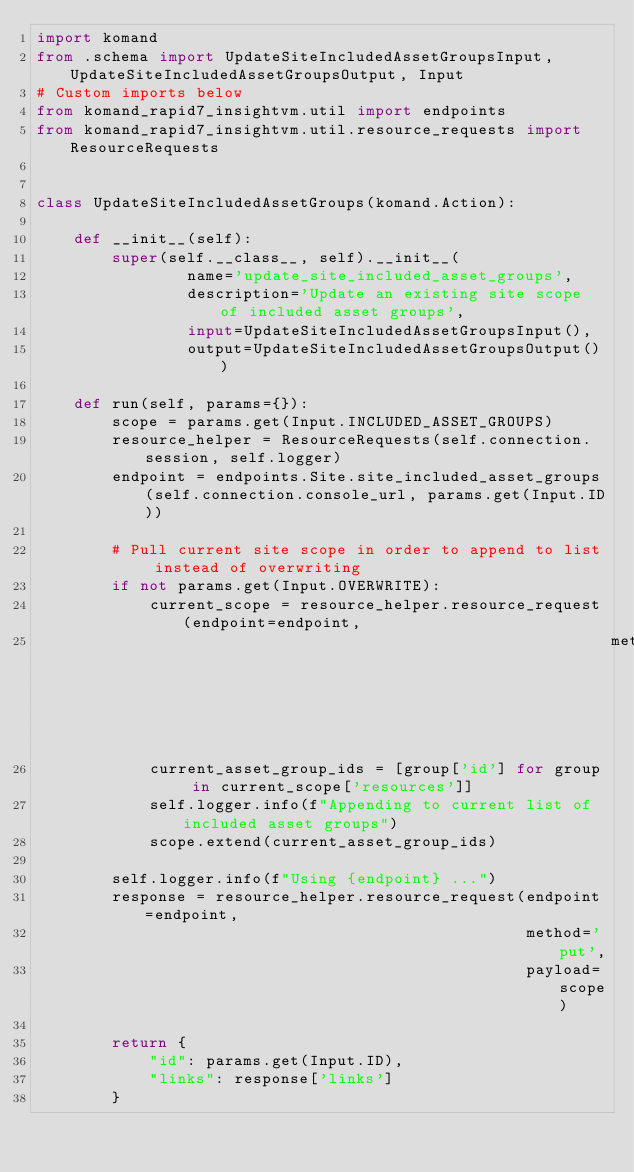Convert code to text. <code><loc_0><loc_0><loc_500><loc_500><_Python_>import komand
from .schema import UpdateSiteIncludedAssetGroupsInput, UpdateSiteIncludedAssetGroupsOutput, Input
# Custom imports below
from komand_rapid7_insightvm.util import endpoints
from komand_rapid7_insightvm.util.resource_requests import ResourceRequests


class UpdateSiteIncludedAssetGroups(komand.Action):

    def __init__(self):
        super(self.__class__, self).__init__(
                name='update_site_included_asset_groups',
                description='Update an existing site scope of included asset groups',
                input=UpdateSiteIncludedAssetGroupsInput(),
                output=UpdateSiteIncludedAssetGroupsOutput())

    def run(self, params={}):
        scope = params.get(Input.INCLUDED_ASSET_GROUPS)
        resource_helper = ResourceRequests(self.connection.session, self.logger)
        endpoint = endpoints.Site.site_included_asset_groups(self.connection.console_url, params.get(Input.ID))

        # Pull current site scope in order to append to list instead of overwriting
        if not params.get(Input.OVERWRITE):
            current_scope = resource_helper.resource_request(endpoint=endpoint,
                                                             method='get')
            current_asset_group_ids = [group['id'] for group in current_scope['resources']]
            self.logger.info(f"Appending to current list of included asset groups")
            scope.extend(current_asset_group_ids)

        self.logger.info(f"Using {endpoint} ...")
        response = resource_helper.resource_request(endpoint=endpoint,
                                                    method='put',
                                                    payload=scope)

        return {
            "id": params.get(Input.ID),
            "links": response['links']
        }
</code> 